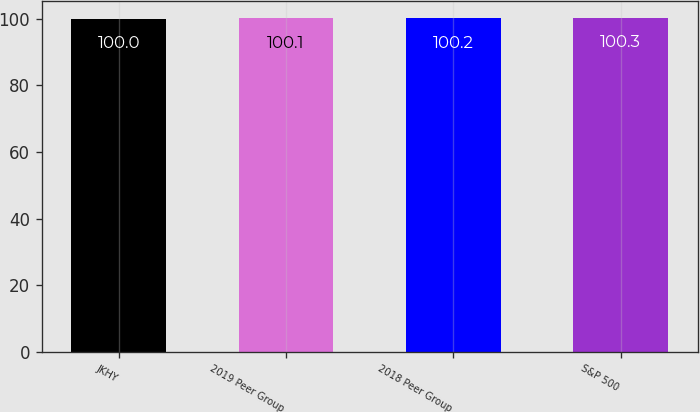<chart> <loc_0><loc_0><loc_500><loc_500><bar_chart><fcel>JKHY<fcel>2019 Peer Group<fcel>2018 Peer Group<fcel>S&P 500<nl><fcel>100<fcel>100.1<fcel>100.2<fcel>100.3<nl></chart> 